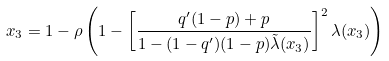Convert formula to latex. <formula><loc_0><loc_0><loc_500><loc_500>x _ { 3 } = 1 - \rho \left ( 1 - \left [ \frac { q ^ { \prime } ( 1 - p ) + p } { 1 - ( 1 - q ^ { \prime } ) ( 1 - p ) \tilde { \lambda } ( x _ { 3 } ) } \right ] ^ { 2 } \lambda ( x _ { 3 } ) \right )</formula> 